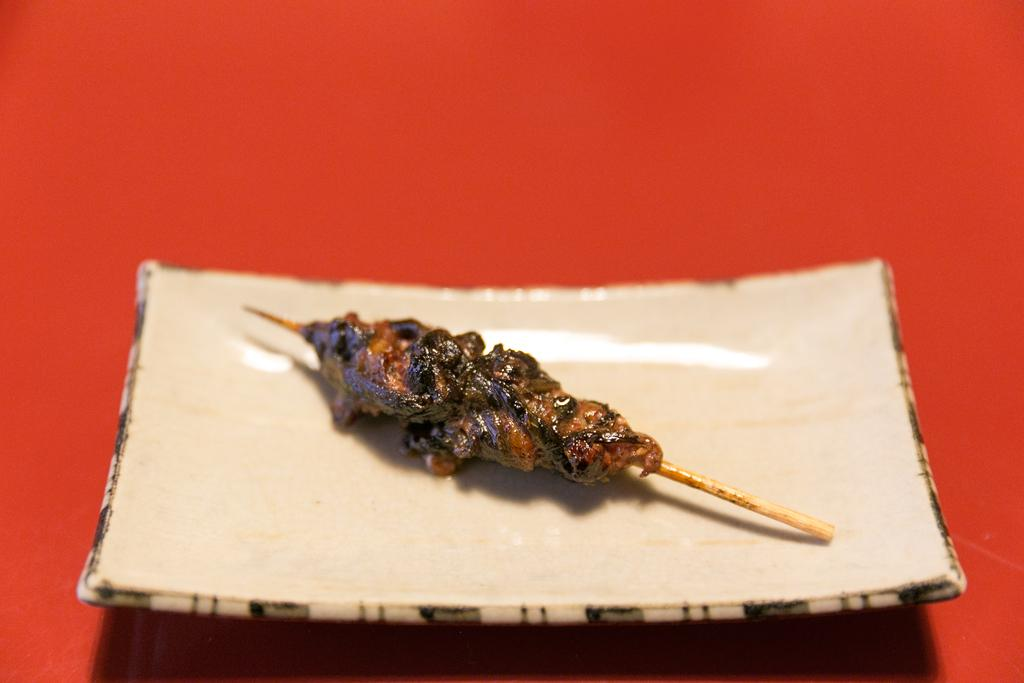What types of food items are present in the image? There are food items in the image, but their specific types are not mentioned in the facts. On what object are the food items placed? The food items are on an object, but the specific type of object is not mentioned in the facts. What is the color of the surface on which the object is placed? The surface on which the object is placed is red in color. What type of neck accessory is visible in the image? There is no neck accessory present in the image. What hobbies are the food items engaged in within the image? Food items do not have hobbies, as they are inanimate objects. 